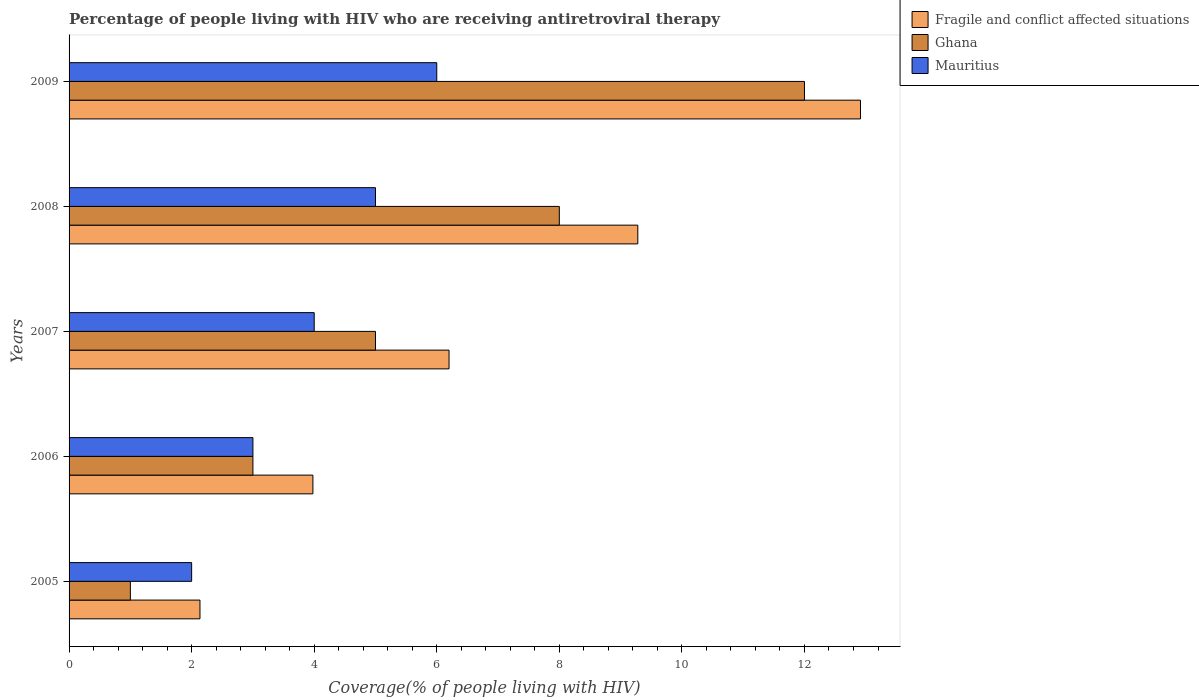How many groups of bars are there?
Offer a very short reply. 5. In how many cases, is the number of bars for a given year not equal to the number of legend labels?
Keep it short and to the point. 0. What is the percentage of the HIV infected people who are receiving antiretroviral therapy in Mauritius in 2005?
Offer a very short reply. 2. Across all years, what is the maximum percentage of the HIV infected people who are receiving antiretroviral therapy in Fragile and conflict affected situations?
Provide a succinct answer. 12.91. Across all years, what is the minimum percentage of the HIV infected people who are receiving antiretroviral therapy in Ghana?
Offer a very short reply. 1. In which year was the percentage of the HIV infected people who are receiving antiretroviral therapy in Mauritius maximum?
Your answer should be very brief. 2009. What is the total percentage of the HIV infected people who are receiving antiretroviral therapy in Fragile and conflict affected situations in the graph?
Provide a short and direct response. 34.51. What is the difference between the percentage of the HIV infected people who are receiving antiretroviral therapy in Ghana in 2006 and that in 2008?
Keep it short and to the point. -5. What is the difference between the percentage of the HIV infected people who are receiving antiretroviral therapy in Ghana in 2009 and the percentage of the HIV infected people who are receiving antiretroviral therapy in Fragile and conflict affected situations in 2008?
Your response must be concise. 2.72. What is the average percentage of the HIV infected people who are receiving antiretroviral therapy in Fragile and conflict affected situations per year?
Provide a short and direct response. 6.9. In the year 2006, what is the difference between the percentage of the HIV infected people who are receiving antiretroviral therapy in Ghana and percentage of the HIV infected people who are receiving antiretroviral therapy in Fragile and conflict affected situations?
Your answer should be compact. -0.98. In how many years, is the percentage of the HIV infected people who are receiving antiretroviral therapy in Fragile and conflict affected situations greater than 4 %?
Provide a succinct answer. 3. What is the ratio of the percentage of the HIV infected people who are receiving antiretroviral therapy in Mauritius in 2006 to that in 2009?
Provide a succinct answer. 0.5. Is the percentage of the HIV infected people who are receiving antiretroviral therapy in Mauritius in 2005 less than that in 2007?
Make the answer very short. Yes. Is the difference between the percentage of the HIV infected people who are receiving antiretroviral therapy in Ghana in 2005 and 2006 greater than the difference between the percentage of the HIV infected people who are receiving antiretroviral therapy in Fragile and conflict affected situations in 2005 and 2006?
Your answer should be very brief. No. What is the difference between the highest and the second highest percentage of the HIV infected people who are receiving antiretroviral therapy in Fragile and conflict affected situations?
Your answer should be compact. 3.63. What is the difference between the highest and the lowest percentage of the HIV infected people who are receiving antiretroviral therapy in Fragile and conflict affected situations?
Your answer should be compact. 10.78. In how many years, is the percentage of the HIV infected people who are receiving antiretroviral therapy in Fragile and conflict affected situations greater than the average percentage of the HIV infected people who are receiving antiretroviral therapy in Fragile and conflict affected situations taken over all years?
Offer a terse response. 2. What does the 1st bar from the top in 2008 represents?
Your response must be concise. Mauritius. How many bars are there?
Provide a short and direct response. 15. Are all the bars in the graph horizontal?
Provide a succinct answer. Yes. Does the graph contain any zero values?
Offer a very short reply. No. How many legend labels are there?
Offer a very short reply. 3. How are the legend labels stacked?
Offer a very short reply. Vertical. What is the title of the graph?
Your answer should be compact. Percentage of people living with HIV who are receiving antiretroviral therapy. Does "Israel" appear as one of the legend labels in the graph?
Ensure brevity in your answer.  No. What is the label or title of the X-axis?
Provide a succinct answer. Coverage(% of people living with HIV). What is the Coverage(% of people living with HIV) of Fragile and conflict affected situations in 2005?
Give a very brief answer. 2.14. What is the Coverage(% of people living with HIV) in Ghana in 2005?
Your answer should be very brief. 1. What is the Coverage(% of people living with HIV) of Mauritius in 2005?
Provide a short and direct response. 2. What is the Coverage(% of people living with HIV) in Fragile and conflict affected situations in 2006?
Ensure brevity in your answer.  3.98. What is the Coverage(% of people living with HIV) of Ghana in 2006?
Give a very brief answer. 3. What is the Coverage(% of people living with HIV) in Mauritius in 2006?
Provide a succinct answer. 3. What is the Coverage(% of people living with HIV) of Fragile and conflict affected situations in 2007?
Ensure brevity in your answer.  6.2. What is the Coverage(% of people living with HIV) of Ghana in 2007?
Your answer should be very brief. 5. What is the Coverage(% of people living with HIV) of Mauritius in 2007?
Your answer should be compact. 4. What is the Coverage(% of people living with HIV) in Fragile and conflict affected situations in 2008?
Make the answer very short. 9.28. What is the Coverage(% of people living with HIV) in Ghana in 2008?
Make the answer very short. 8. What is the Coverage(% of people living with HIV) in Fragile and conflict affected situations in 2009?
Ensure brevity in your answer.  12.91. Across all years, what is the maximum Coverage(% of people living with HIV) in Fragile and conflict affected situations?
Keep it short and to the point. 12.91. Across all years, what is the minimum Coverage(% of people living with HIV) of Fragile and conflict affected situations?
Provide a short and direct response. 2.14. Across all years, what is the minimum Coverage(% of people living with HIV) in Ghana?
Your answer should be compact. 1. Across all years, what is the minimum Coverage(% of people living with HIV) of Mauritius?
Offer a very short reply. 2. What is the total Coverage(% of people living with HIV) in Fragile and conflict affected situations in the graph?
Your answer should be compact. 34.51. What is the total Coverage(% of people living with HIV) of Ghana in the graph?
Provide a succinct answer. 29. What is the total Coverage(% of people living with HIV) in Mauritius in the graph?
Provide a succinct answer. 20. What is the difference between the Coverage(% of people living with HIV) of Fragile and conflict affected situations in 2005 and that in 2006?
Give a very brief answer. -1.84. What is the difference between the Coverage(% of people living with HIV) of Mauritius in 2005 and that in 2006?
Your answer should be compact. -1. What is the difference between the Coverage(% of people living with HIV) in Fragile and conflict affected situations in 2005 and that in 2007?
Give a very brief answer. -4.06. What is the difference between the Coverage(% of people living with HIV) of Mauritius in 2005 and that in 2007?
Offer a terse response. -2. What is the difference between the Coverage(% of people living with HIV) of Fragile and conflict affected situations in 2005 and that in 2008?
Your answer should be very brief. -7.14. What is the difference between the Coverage(% of people living with HIV) of Ghana in 2005 and that in 2008?
Offer a very short reply. -7. What is the difference between the Coverage(% of people living with HIV) of Fragile and conflict affected situations in 2005 and that in 2009?
Your response must be concise. -10.78. What is the difference between the Coverage(% of people living with HIV) of Fragile and conflict affected situations in 2006 and that in 2007?
Your answer should be very brief. -2.22. What is the difference between the Coverage(% of people living with HIV) of Ghana in 2006 and that in 2007?
Ensure brevity in your answer.  -2. What is the difference between the Coverage(% of people living with HIV) in Fragile and conflict affected situations in 2006 and that in 2008?
Offer a terse response. -5.3. What is the difference between the Coverage(% of people living with HIV) in Ghana in 2006 and that in 2008?
Your response must be concise. -5. What is the difference between the Coverage(% of people living with HIV) in Fragile and conflict affected situations in 2006 and that in 2009?
Offer a terse response. -8.94. What is the difference between the Coverage(% of people living with HIV) of Mauritius in 2006 and that in 2009?
Give a very brief answer. -3. What is the difference between the Coverage(% of people living with HIV) of Fragile and conflict affected situations in 2007 and that in 2008?
Give a very brief answer. -3.08. What is the difference between the Coverage(% of people living with HIV) in Ghana in 2007 and that in 2008?
Your answer should be very brief. -3. What is the difference between the Coverage(% of people living with HIV) of Fragile and conflict affected situations in 2007 and that in 2009?
Keep it short and to the point. -6.71. What is the difference between the Coverage(% of people living with HIV) of Mauritius in 2007 and that in 2009?
Offer a very short reply. -2. What is the difference between the Coverage(% of people living with HIV) of Fragile and conflict affected situations in 2008 and that in 2009?
Your response must be concise. -3.63. What is the difference between the Coverage(% of people living with HIV) of Fragile and conflict affected situations in 2005 and the Coverage(% of people living with HIV) of Ghana in 2006?
Your answer should be very brief. -0.86. What is the difference between the Coverage(% of people living with HIV) of Fragile and conflict affected situations in 2005 and the Coverage(% of people living with HIV) of Mauritius in 2006?
Your response must be concise. -0.86. What is the difference between the Coverage(% of people living with HIV) in Ghana in 2005 and the Coverage(% of people living with HIV) in Mauritius in 2006?
Your response must be concise. -2. What is the difference between the Coverage(% of people living with HIV) of Fragile and conflict affected situations in 2005 and the Coverage(% of people living with HIV) of Ghana in 2007?
Provide a succinct answer. -2.86. What is the difference between the Coverage(% of people living with HIV) in Fragile and conflict affected situations in 2005 and the Coverage(% of people living with HIV) in Mauritius in 2007?
Your response must be concise. -1.86. What is the difference between the Coverage(% of people living with HIV) in Fragile and conflict affected situations in 2005 and the Coverage(% of people living with HIV) in Ghana in 2008?
Offer a very short reply. -5.86. What is the difference between the Coverage(% of people living with HIV) of Fragile and conflict affected situations in 2005 and the Coverage(% of people living with HIV) of Mauritius in 2008?
Ensure brevity in your answer.  -2.86. What is the difference between the Coverage(% of people living with HIV) of Ghana in 2005 and the Coverage(% of people living with HIV) of Mauritius in 2008?
Offer a very short reply. -4. What is the difference between the Coverage(% of people living with HIV) in Fragile and conflict affected situations in 2005 and the Coverage(% of people living with HIV) in Ghana in 2009?
Provide a succinct answer. -9.86. What is the difference between the Coverage(% of people living with HIV) in Fragile and conflict affected situations in 2005 and the Coverage(% of people living with HIV) in Mauritius in 2009?
Ensure brevity in your answer.  -3.86. What is the difference between the Coverage(% of people living with HIV) in Ghana in 2005 and the Coverage(% of people living with HIV) in Mauritius in 2009?
Provide a short and direct response. -5. What is the difference between the Coverage(% of people living with HIV) in Fragile and conflict affected situations in 2006 and the Coverage(% of people living with HIV) in Ghana in 2007?
Provide a succinct answer. -1.02. What is the difference between the Coverage(% of people living with HIV) in Fragile and conflict affected situations in 2006 and the Coverage(% of people living with HIV) in Mauritius in 2007?
Give a very brief answer. -0.02. What is the difference between the Coverage(% of people living with HIV) in Ghana in 2006 and the Coverage(% of people living with HIV) in Mauritius in 2007?
Offer a terse response. -1. What is the difference between the Coverage(% of people living with HIV) in Fragile and conflict affected situations in 2006 and the Coverage(% of people living with HIV) in Ghana in 2008?
Offer a very short reply. -4.02. What is the difference between the Coverage(% of people living with HIV) of Fragile and conflict affected situations in 2006 and the Coverage(% of people living with HIV) of Mauritius in 2008?
Your response must be concise. -1.02. What is the difference between the Coverage(% of people living with HIV) of Fragile and conflict affected situations in 2006 and the Coverage(% of people living with HIV) of Ghana in 2009?
Your response must be concise. -8.02. What is the difference between the Coverage(% of people living with HIV) in Fragile and conflict affected situations in 2006 and the Coverage(% of people living with HIV) in Mauritius in 2009?
Offer a very short reply. -2.02. What is the difference between the Coverage(% of people living with HIV) of Fragile and conflict affected situations in 2007 and the Coverage(% of people living with HIV) of Ghana in 2008?
Keep it short and to the point. -1.8. What is the difference between the Coverage(% of people living with HIV) in Fragile and conflict affected situations in 2007 and the Coverage(% of people living with HIV) in Mauritius in 2008?
Your answer should be compact. 1.2. What is the difference between the Coverage(% of people living with HIV) of Ghana in 2007 and the Coverage(% of people living with HIV) of Mauritius in 2008?
Offer a very short reply. 0. What is the difference between the Coverage(% of people living with HIV) in Fragile and conflict affected situations in 2007 and the Coverage(% of people living with HIV) in Ghana in 2009?
Provide a short and direct response. -5.8. What is the difference between the Coverage(% of people living with HIV) in Fragile and conflict affected situations in 2007 and the Coverage(% of people living with HIV) in Mauritius in 2009?
Offer a very short reply. 0.2. What is the difference between the Coverage(% of people living with HIV) in Ghana in 2007 and the Coverage(% of people living with HIV) in Mauritius in 2009?
Make the answer very short. -1. What is the difference between the Coverage(% of people living with HIV) in Fragile and conflict affected situations in 2008 and the Coverage(% of people living with HIV) in Ghana in 2009?
Ensure brevity in your answer.  -2.72. What is the difference between the Coverage(% of people living with HIV) in Fragile and conflict affected situations in 2008 and the Coverage(% of people living with HIV) in Mauritius in 2009?
Your answer should be very brief. 3.28. What is the average Coverage(% of people living with HIV) in Fragile and conflict affected situations per year?
Your answer should be very brief. 6.9. What is the average Coverage(% of people living with HIV) of Ghana per year?
Your response must be concise. 5.8. What is the average Coverage(% of people living with HIV) of Mauritius per year?
Offer a terse response. 4. In the year 2005, what is the difference between the Coverage(% of people living with HIV) in Fragile and conflict affected situations and Coverage(% of people living with HIV) in Ghana?
Provide a short and direct response. 1.14. In the year 2005, what is the difference between the Coverage(% of people living with HIV) in Fragile and conflict affected situations and Coverage(% of people living with HIV) in Mauritius?
Ensure brevity in your answer.  0.14. In the year 2005, what is the difference between the Coverage(% of people living with HIV) in Ghana and Coverage(% of people living with HIV) in Mauritius?
Provide a succinct answer. -1. In the year 2006, what is the difference between the Coverage(% of people living with HIV) in Ghana and Coverage(% of people living with HIV) in Mauritius?
Your response must be concise. 0. In the year 2007, what is the difference between the Coverage(% of people living with HIV) of Fragile and conflict affected situations and Coverage(% of people living with HIV) of Ghana?
Your response must be concise. 1.2. In the year 2007, what is the difference between the Coverage(% of people living with HIV) in Fragile and conflict affected situations and Coverage(% of people living with HIV) in Mauritius?
Give a very brief answer. 2.2. In the year 2007, what is the difference between the Coverage(% of people living with HIV) of Ghana and Coverage(% of people living with HIV) of Mauritius?
Your answer should be compact. 1. In the year 2008, what is the difference between the Coverage(% of people living with HIV) in Fragile and conflict affected situations and Coverage(% of people living with HIV) in Ghana?
Ensure brevity in your answer.  1.28. In the year 2008, what is the difference between the Coverage(% of people living with HIV) in Fragile and conflict affected situations and Coverage(% of people living with HIV) in Mauritius?
Give a very brief answer. 4.28. In the year 2008, what is the difference between the Coverage(% of people living with HIV) in Ghana and Coverage(% of people living with HIV) in Mauritius?
Provide a short and direct response. 3. In the year 2009, what is the difference between the Coverage(% of people living with HIV) of Fragile and conflict affected situations and Coverage(% of people living with HIV) of Ghana?
Your answer should be compact. 0.91. In the year 2009, what is the difference between the Coverage(% of people living with HIV) in Fragile and conflict affected situations and Coverage(% of people living with HIV) in Mauritius?
Offer a very short reply. 6.91. In the year 2009, what is the difference between the Coverage(% of people living with HIV) in Ghana and Coverage(% of people living with HIV) in Mauritius?
Ensure brevity in your answer.  6. What is the ratio of the Coverage(% of people living with HIV) in Fragile and conflict affected situations in 2005 to that in 2006?
Your response must be concise. 0.54. What is the ratio of the Coverage(% of people living with HIV) of Ghana in 2005 to that in 2006?
Your answer should be very brief. 0.33. What is the ratio of the Coverage(% of people living with HIV) in Fragile and conflict affected situations in 2005 to that in 2007?
Your answer should be very brief. 0.34. What is the ratio of the Coverage(% of people living with HIV) in Ghana in 2005 to that in 2007?
Your response must be concise. 0.2. What is the ratio of the Coverage(% of people living with HIV) of Fragile and conflict affected situations in 2005 to that in 2008?
Your answer should be compact. 0.23. What is the ratio of the Coverage(% of people living with HIV) in Mauritius in 2005 to that in 2008?
Provide a short and direct response. 0.4. What is the ratio of the Coverage(% of people living with HIV) of Fragile and conflict affected situations in 2005 to that in 2009?
Ensure brevity in your answer.  0.17. What is the ratio of the Coverage(% of people living with HIV) in Ghana in 2005 to that in 2009?
Provide a short and direct response. 0.08. What is the ratio of the Coverage(% of people living with HIV) of Fragile and conflict affected situations in 2006 to that in 2007?
Provide a succinct answer. 0.64. What is the ratio of the Coverage(% of people living with HIV) of Ghana in 2006 to that in 2007?
Give a very brief answer. 0.6. What is the ratio of the Coverage(% of people living with HIV) in Fragile and conflict affected situations in 2006 to that in 2008?
Your answer should be compact. 0.43. What is the ratio of the Coverage(% of people living with HIV) of Fragile and conflict affected situations in 2006 to that in 2009?
Make the answer very short. 0.31. What is the ratio of the Coverage(% of people living with HIV) in Ghana in 2006 to that in 2009?
Provide a short and direct response. 0.25. What is the ratio of the Coverage(% of people living with HIV) of Mauritius in 2006 to that in 2009?
Provide a succinct answer. 0.5. What is the ratio of the Coverage(% of people living with HIV) of Fragile and conflict affected situations in 2007 to that in 2008?
Your answer should be very brief. 0.67. What is the ratio of the Coverage(% of people living with HIV) in Mauritius in 2007 to that in 2008?
Make the answer very short. 0.8. What is the ratio of the Coverage(% of people living with HIV) in Fragile and conflict affected situations in 2007 to that in 2009?
Provide a short and direct response. 0.48. What is the ratio of the Coverage(% of people living with HIV) of Ghana in 2007 to that in 2009?
Your answer should be compact. 0.42. What is the ratio of the Coverage(% of people living with HIV) in Mauritius in 2007 to that in 2009?
Provide a succinct answer. 0.67. What is the ratio of the Coverage(% of people living with HIV) of Fragile and conflict affected situations in 2008 to that in 2009?
Ensure brevity in your answer.  0.72. What is the ratio of the Coverage(% of people living with HIV) in Mauritius in 2008 to that in 2009?
Your answer should be compact. 0.83. What is the difference between the highest and the second highest Coverage(% of people living with HIV) of Fragile and conflict affected situations?
Provide a succinct answer. 3.63. What is the difference between the highest and the second highest Coverage(% of people living with HIV) in Ghana?
Offer a very short reply. 4. What is the difference between the highest and the second highest Coverage(% of people living with HIV) in Mauritius?
Make the answer very short. 1. What is the difference between the highest and the lowest Coverage(% of people living with HIV) of Fragile and conflict affected situations?
Provide a short and direct response. 10.78. What is the difference between the highest and the lowest Coverage(% of people living with HIV) of Ghana?
Give a very brief answer. 11. 